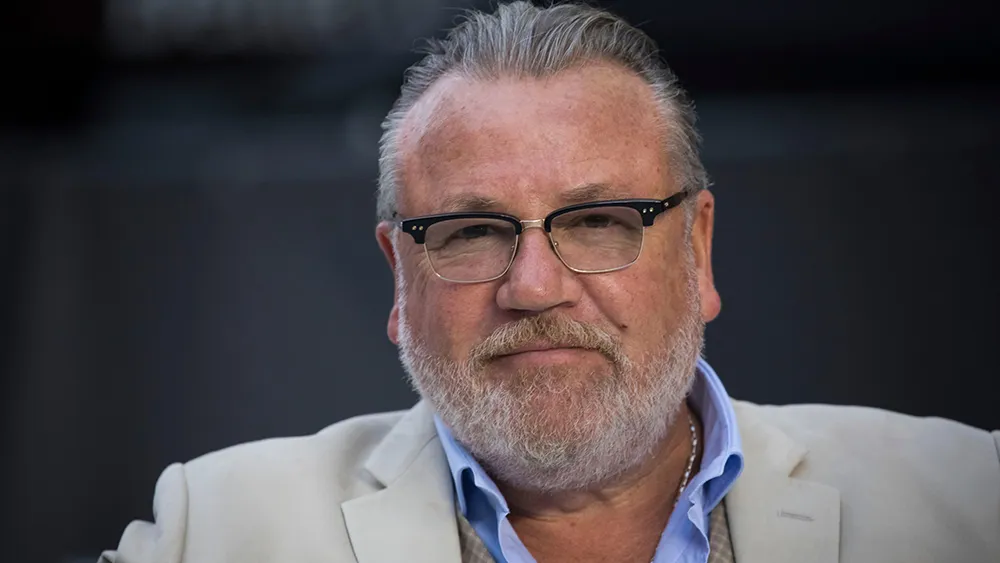Can you describe the setting of this image? The blurred background in the image, with soft lighting and indistinct shapes, implies a formal setting, perhaps an indoor event or conference. This backdrop hints at a professional environment, perhaps designed to focus attention fully on the individual, framing him as the focal point of interest. 